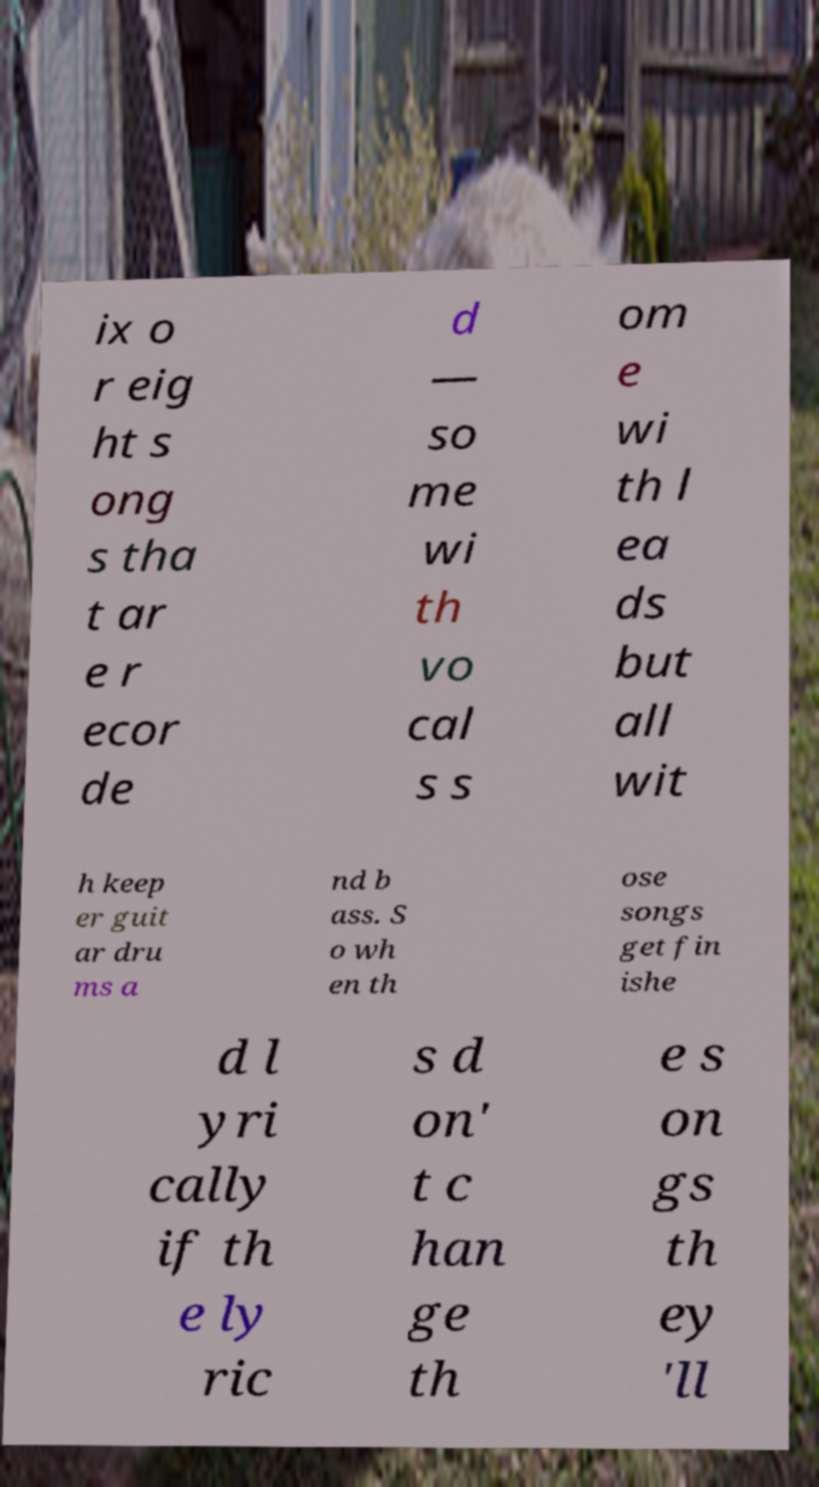Can you read and provide the text displayed in the image?This photo seems to have some interesting text. Can you extract and type it out for me? ix o r eig ht s ong s tha t ar e r ecor de d — so me wi th vo cal s s om e wi th l ea ds but all wit h keep er guit ar dru ms a nd b ass. S o wh en th ose songs get fin ishe d l yri cally if th e ly ric s d on' t c han ge th e s on gs th ey 'll 